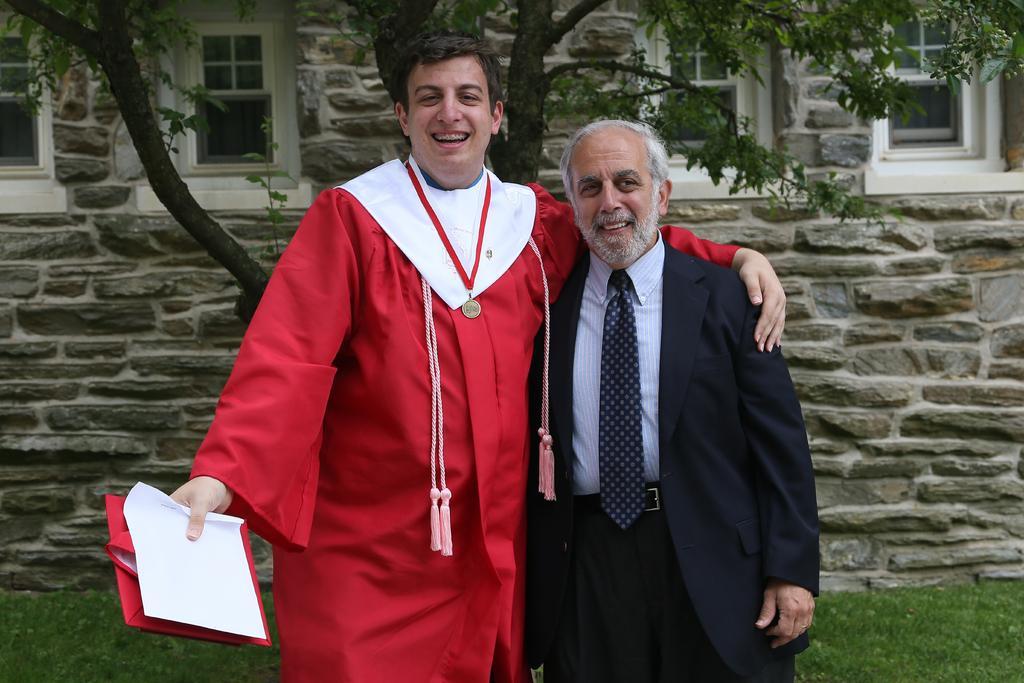Can you describe this image briefly? In this image I can see there are two men standing, the man at right is an old man wearing a blazer and the man at left is holding and cap and wearing a red color coat. In the backdrop there is a tree and a building with windows. 